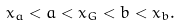Convert formula to latex. <formula><loc_0><loc_0><loc_500><loc_500>x _ { a } < a < x _ { G } < b < x _ { b } .</formula> 